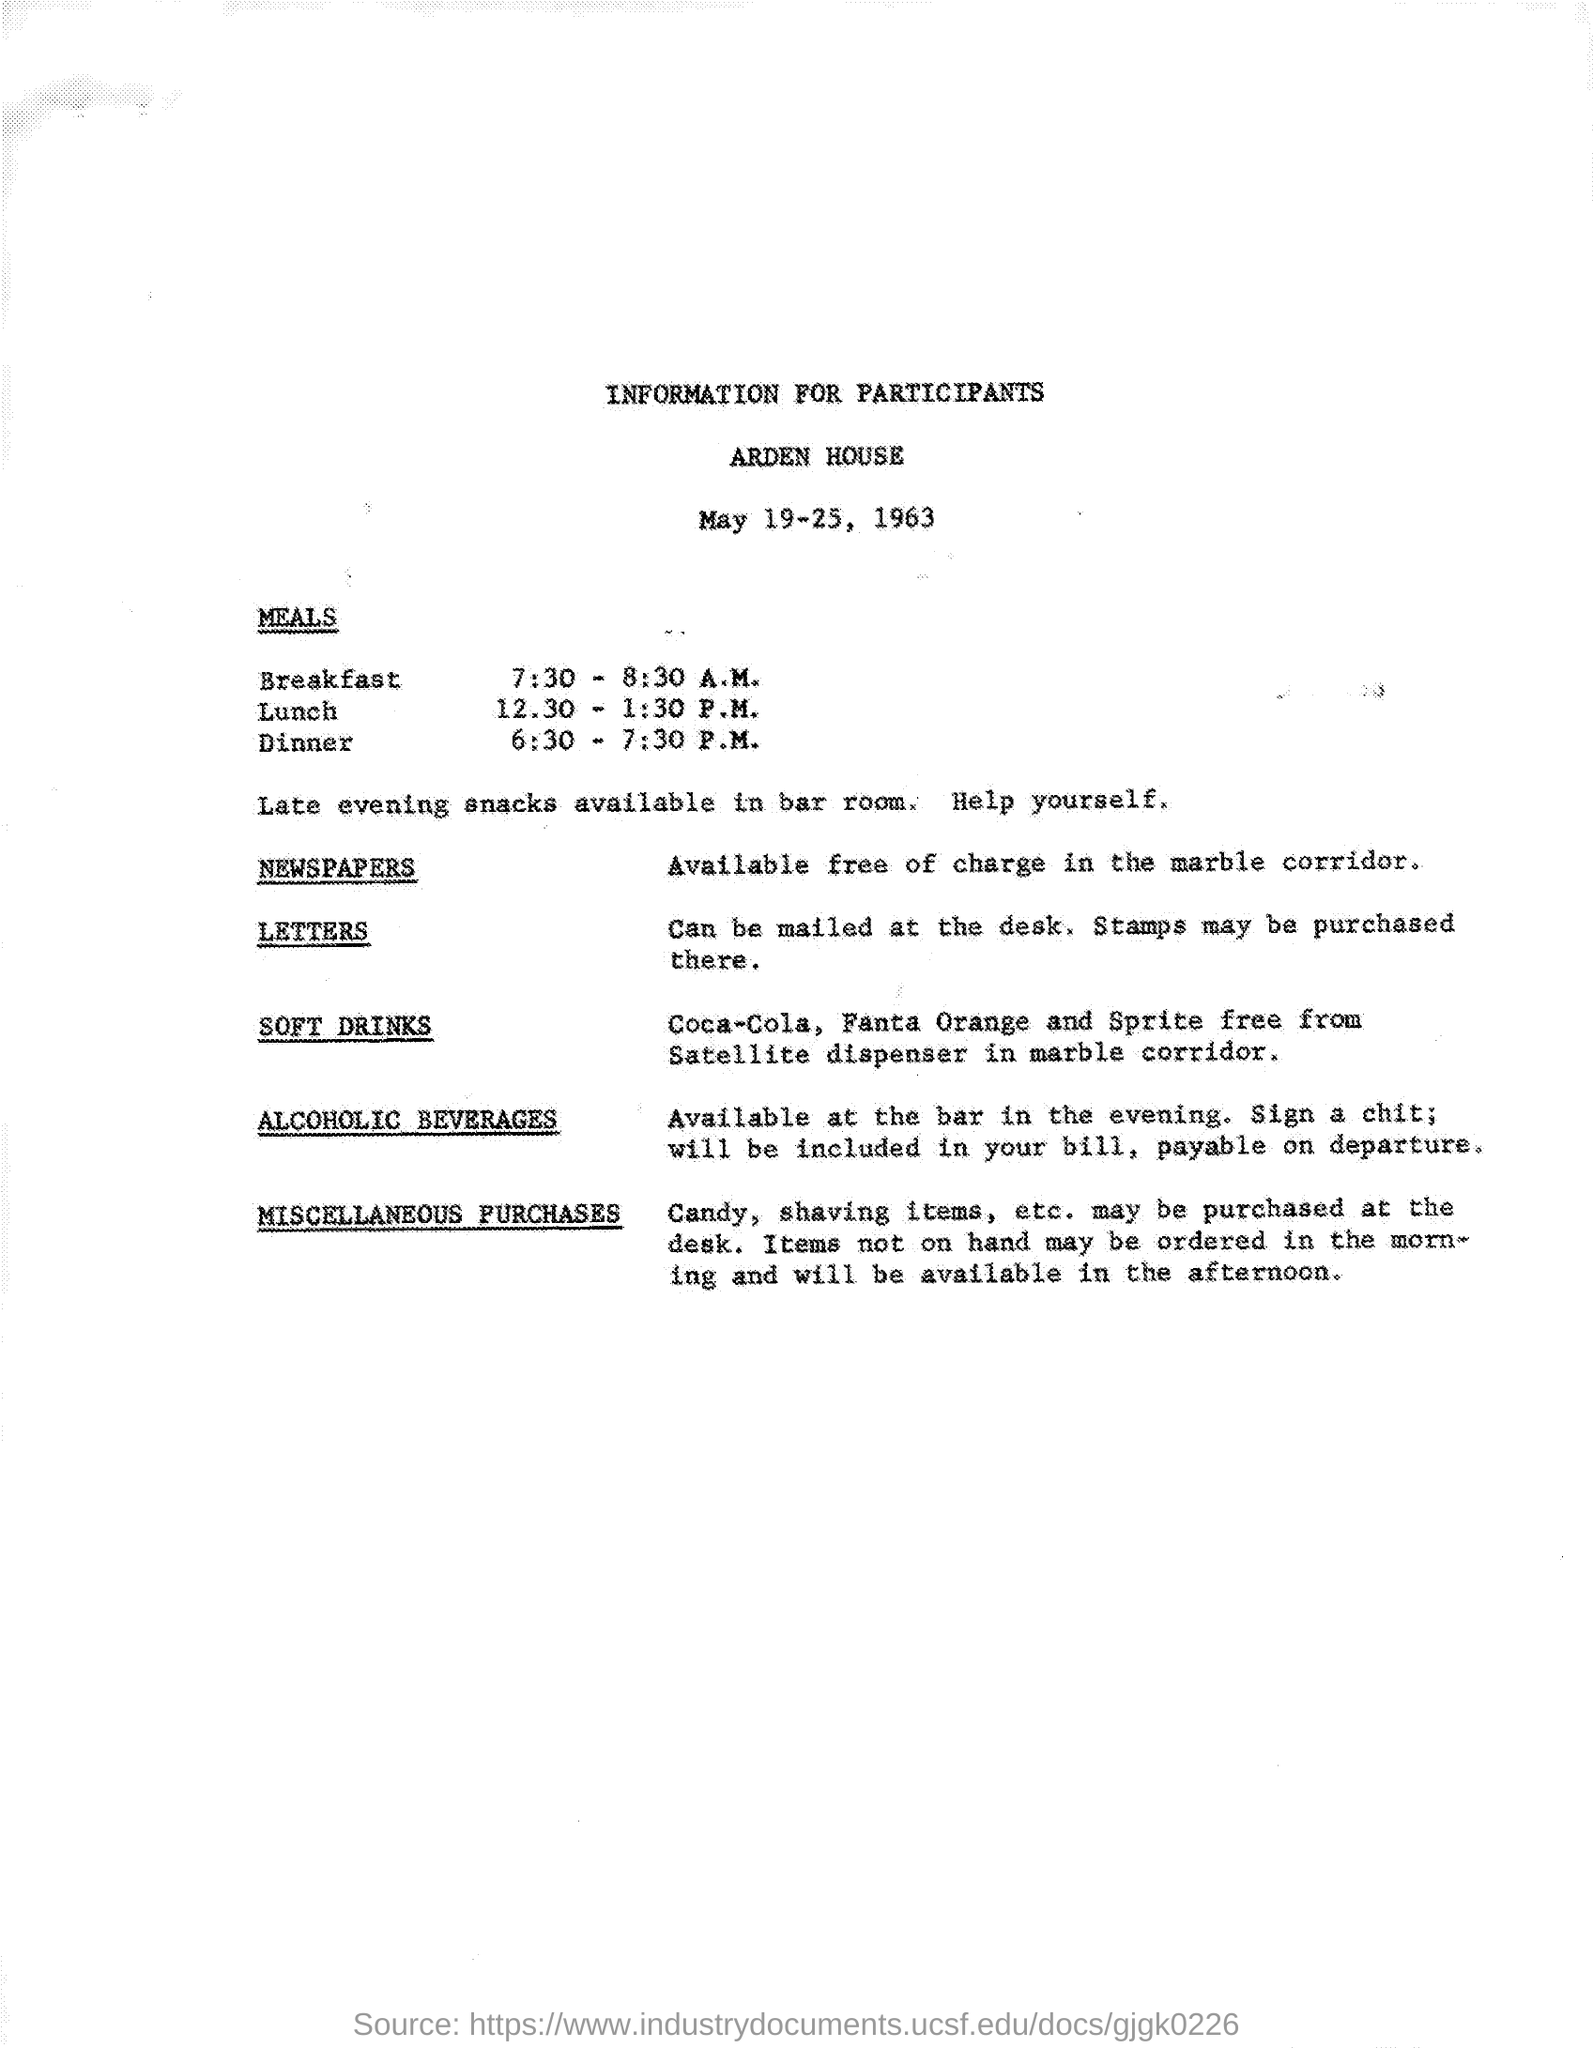What is the Date on the document?
Your response must be concise. May 19-25 1963. 